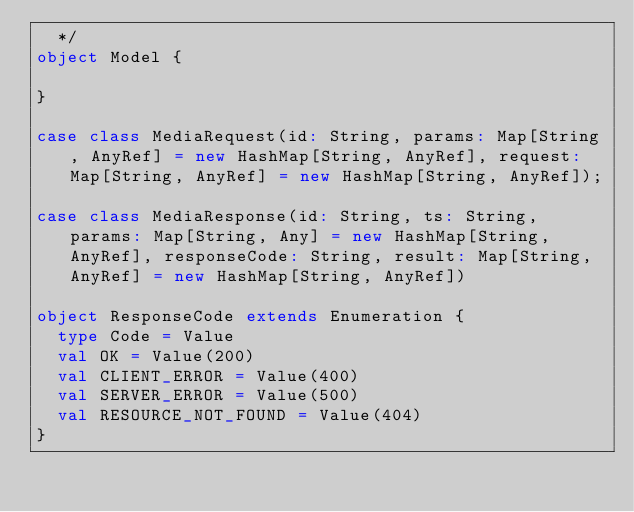Convert code to text. <code><loc_0><loc_0><loc_500><loc_500><_Scala_>  */
object Model {

}

case class MediaRequest(id: String, params: Map[String, AnyRef] = new HashMap[String, AnyRef], request: Map[String, AnyRef] = new HashMap[String, AnyRef]);

case class MediaResponse(id: String, ts: String, params: Map[String, Any] = new HashMap[String, AnyRef], responseCode: String, result: Map[String, AnyRef] = new HashMap[String, AnyRef])

object ResponseCode extends Enumeration {
  type Code = Value
  val OK = Value(200)
  val CLIENT_ERROR = Value(400)
  val SERVER_ERROR = Value(500)
  val RESOURCE_NOT_FOUND = Value(404)
}
</code> 